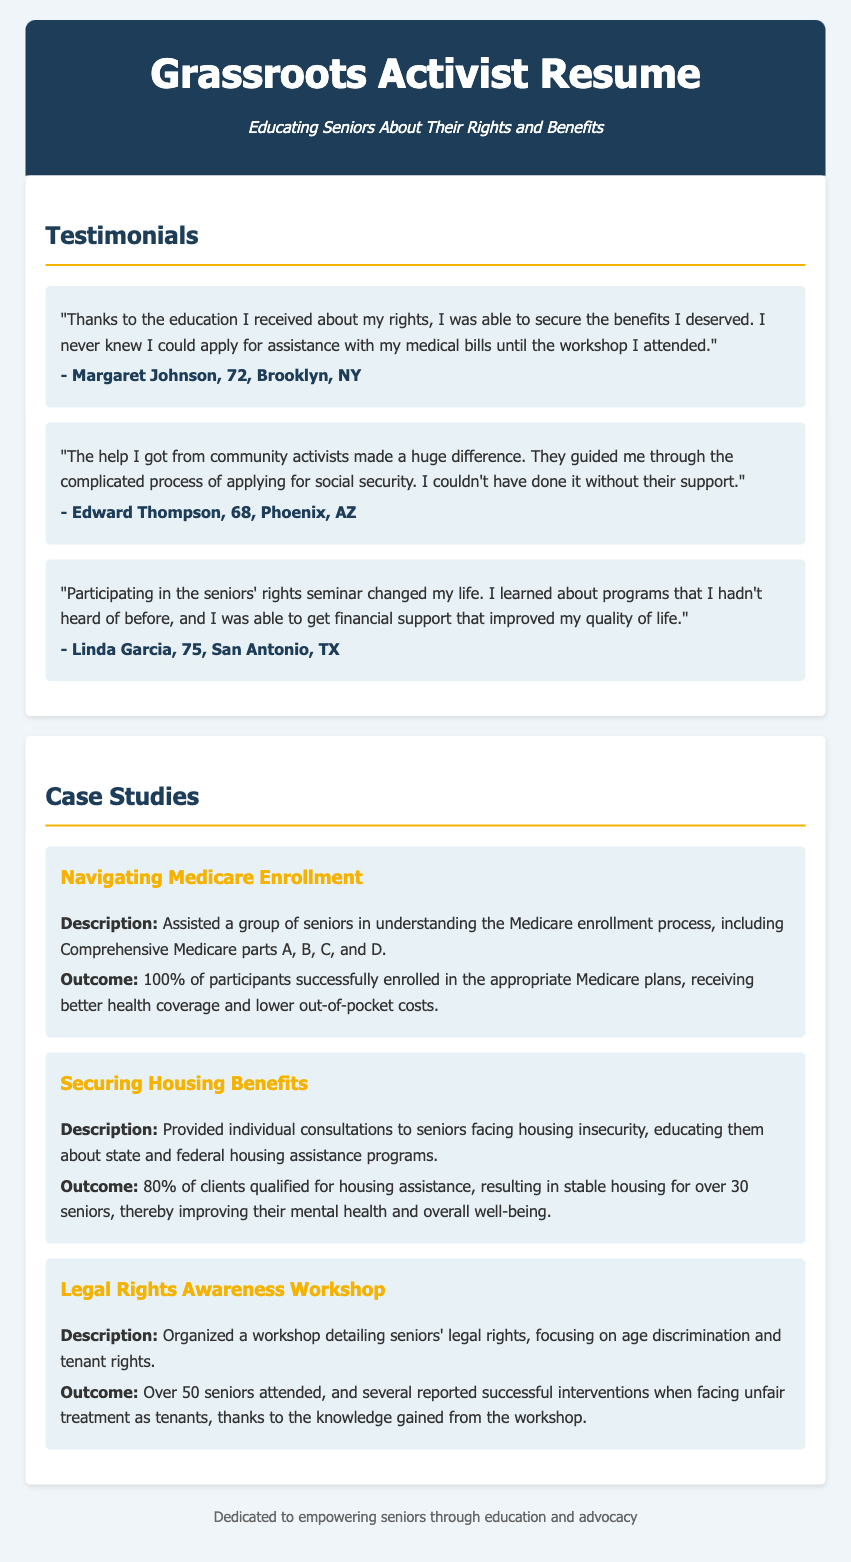What did Margaret Johnson learn about? Margaret Johnson learned about her rights and how to apply for assistance with medical bills.
Answer: assistance with medical bills How many testimonials are included in the document? The document contains three testimonials from seniors.
Answer: three What is the outcome percentage for the housing benefits case study? The case study about securing housing benefits reports that 80% of clients qualified for housing assistance.
Answer: 80% Which state is Edward Thompson from? Edward Thompson is from Phoenix, Arizona.
Answer: Arizona What was the focus of the legal rights awareness workshop? The workshop focused on age discrimination and tenant rights.
Answer: age discrimination and tenant rights How many participants attended the legal rights awareness workshop? More than 50 seniors attended the workshop.
Answer: Over 50 What service was provided in the Medicare enrollment case study? The case study provided assistance in understanding the Medicare enrollment process.
Answer: understanding the Medicare enrollment process What age is Linda Garcia? Linda Garcia is 75 years old.
Answer: 75 What improved for over 30 seniors after receiving housing assistance? Receiving housing assistance improved the mental health and overall well-being of over 30 seniors.
Answer: mental health and overall well-being 